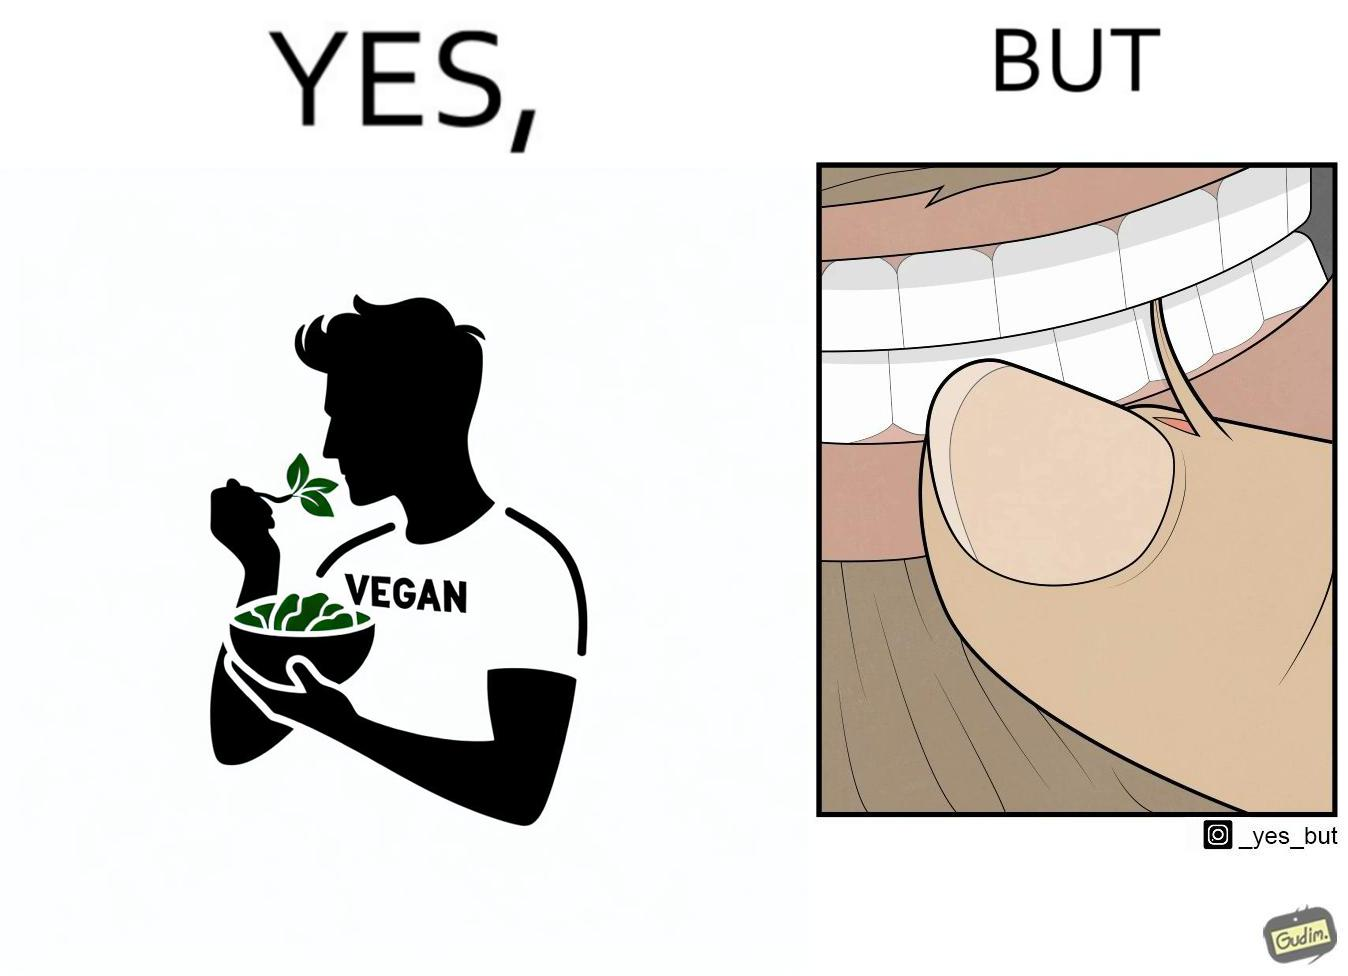Describe what you see in the left and right parts of this image. In the left part of the image: The image shows a man eating leafy vegetables out of a bowl in his hand. He is also wearing a t-shirt that says vegan. In the right part of the image: The image shows a person biting the skin around the fingernails of thier hand. 